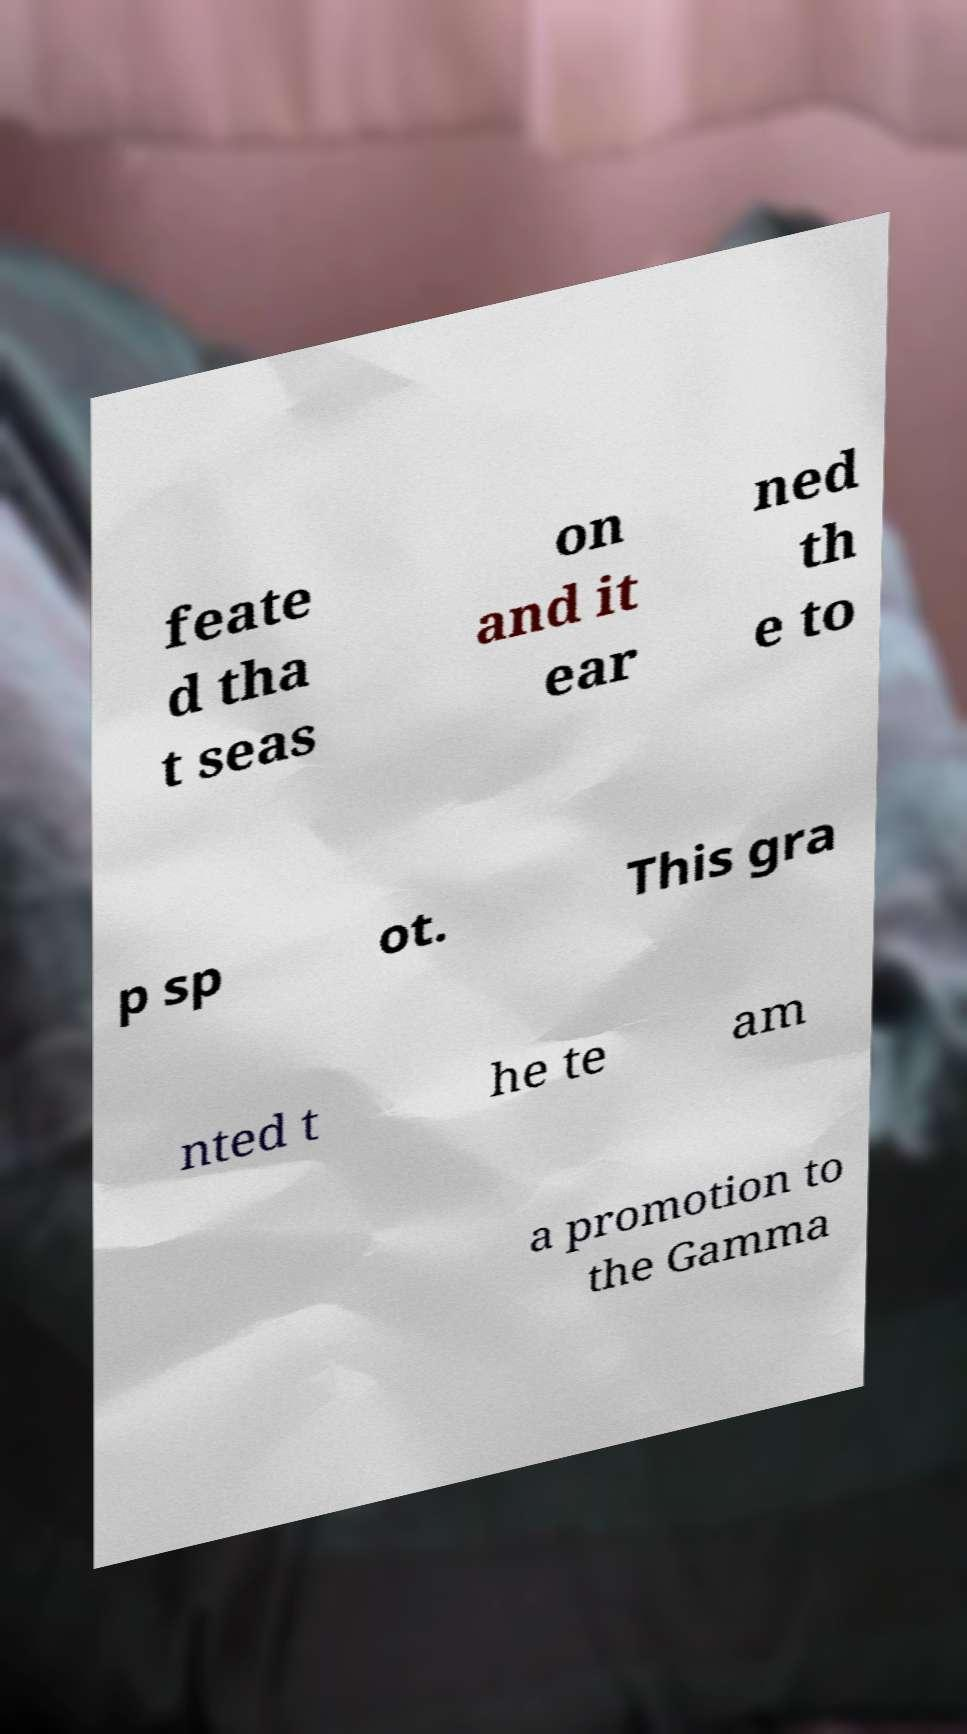Can you read and provide the text displayed in the image?This photo seems to have some interesting text. Can you extract and type it out for me? feate d tha t seas on and it ear ned th e to p sp ot. This gra nted t he te am a promotion to the Gamma 